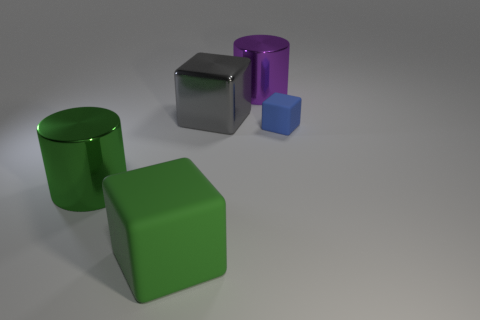Subtract all large cubes. How many cubes are left? 1 Add 1 green metallic blocks. How many objects exist? 6 Subtract all purple cylinders. How many cylinders are left? 1 Subtract all cylinders. How many objects are left? 3 Subtract all gray cylinders. How many green blocks are left? 1 Add 5 big purple metal cylinders. How many big purple metal cylinders exist? 6 Subtract 1 gray cubes. How many objects are left? 4 Subtract 1 cylinders. How many cylinders are left? 1 Subtract all blue cylinders. Subtract all gray balls. How many cylinders are left? 2 Subtract all tiny gray rubber things. Subtract all blocks. How many objects are left? 2 